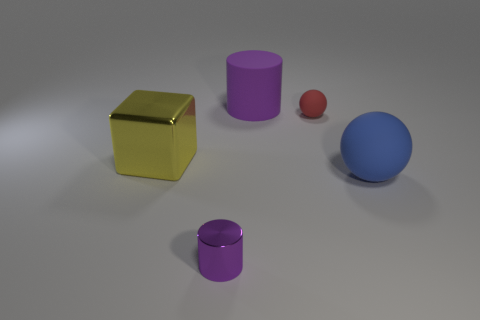Add 2 tiny red rubber objects. How many objects exist? 7 Subtract all red spheres. How many spheres are left? 1 Subtract all cubes. How many objects are left? 4 Subtract 1 balls. How many balls are left? 1 Add 3 tiny matte objects. How many tiny matte objects are left? 4 Add 4 small brown cubes. How many small brown cubes exist? 4 Subtract 0 purple blocks. How many objects are left? 5 Subtract all cyan cubes. Subtract all red balls. How many cubes are left? 1 Subtract all purple balls. How many yellow cylinders are left? 0 Subtract all large gray matte cubes. Subtract all tiny balls. How many objects are left? 4 